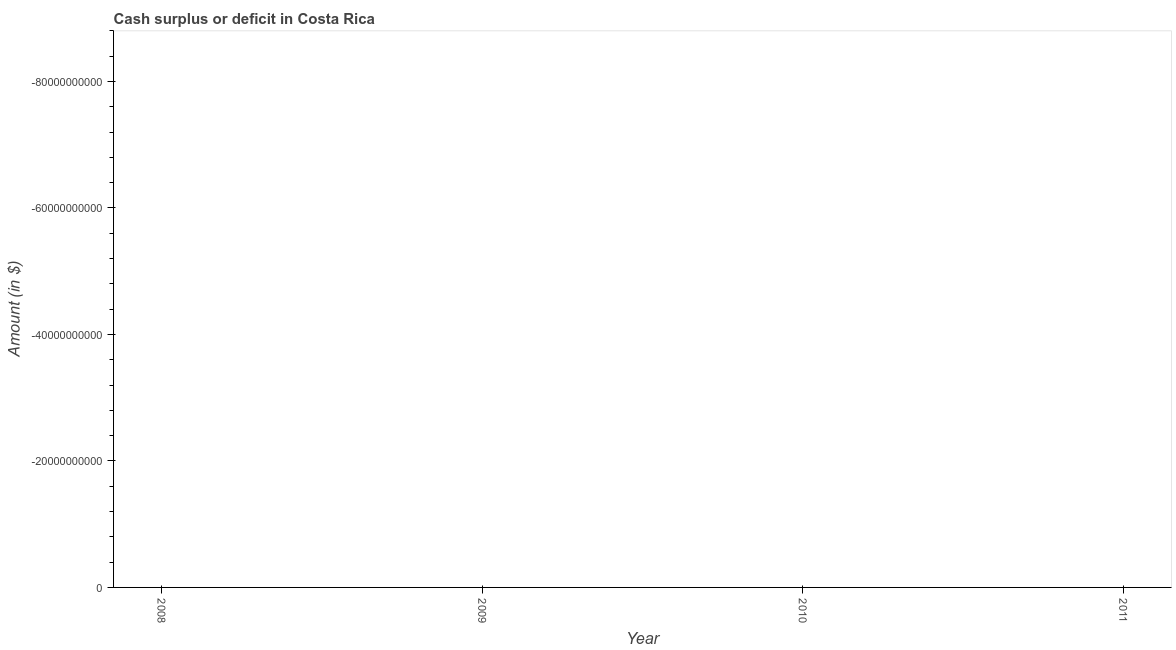Across all years, what is the minimum cash surplus or deficit?
Provide a succinct answer. 0. What is the sum of the cash surplus or deficit?
Your answer should be compact. 0. What is the median cash surplus or deficit?
Give a very brief answer. 0. In how many years, is the cash surplus or deficit greater than -80000000000 $?
Your answer should be very brief. 0. Does the cash surplus or deficit monotonically increase over the years?
Give a very brief answer. No. How many dotlines are there?
Your answer should be compact. 0. How many years are there in the graph?
Offer a very short reply. 4. Does the graph contain grids?
Your answer should be compact. No. What is the title of the graph?
Ensure brevity in your answer.  Cash surplus or deficit in Costa Rica. What is the label or title of the Y-axis?
Your response must be concise. Amount (in $). What is the Amount (in $) in 2009?
Provide a short and direct response. 0. What is the Amount (in $) in 2010?
Offer a very short reply. 0. 